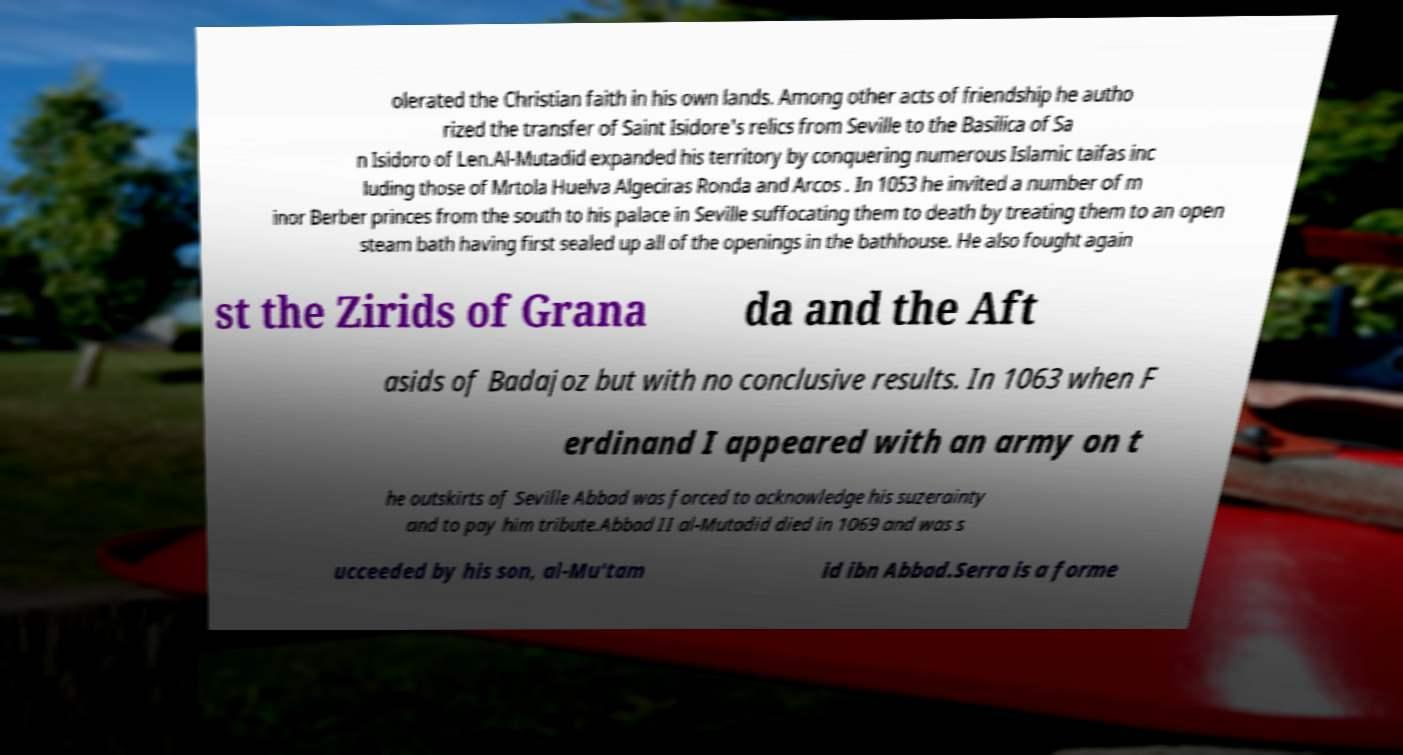There's text embedded in this image that I need extracted. Can you transcribe it verbatim? olerated the Christian faith in his own lands. Among other acts of friendship he autho rized the transfer of Saint Isidore's relics from Seville to the Basilica of Sa n Isidoro of Len.Al-Mutadid expanded his territory by conquering numerous Islamic taifas inc luding those of Mrtola Huelva Algeciras Ronda and Arcos . In 1053 he invited a number of m inor Berber princes from the south to his palace in Seville suffocating them to death by treating them to an open steam bath having first sealed up all of the openings in the bathhouse. He also fought again st the Zirids of Grana da and the Aft asids of Badajoz but with no conclusive results. In 1063 when F erdinand I appeared with an army on t he outskirts of Seville Abbad was forced to acknowledge his suzerainty and to pay him tribute.Abbad II al-Mutadid died in 1069 and was s ucceeded by his son, al-Mu'tam id ibn Abbad.Serra is a forme 